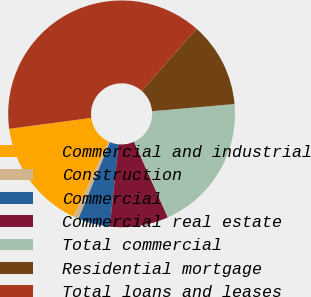Convert chart to OTSL. <chart><loc_0><loc_0><loc_500><loc_500><pie_chart><fcel>Commercial and industrial<fcel>Construction<fcel>Commercial<fcel>Commercial real estate<fcel>Total commercial<fcel>Residential mortgage<fcel>Total loans and leases<nl><fcel>15.91%<fcel>0.77%<fcel>4.56%<fcel>8.34%<fcel>19.69%<fcel>12.12%<fcel>38.61%<nl></chart> 